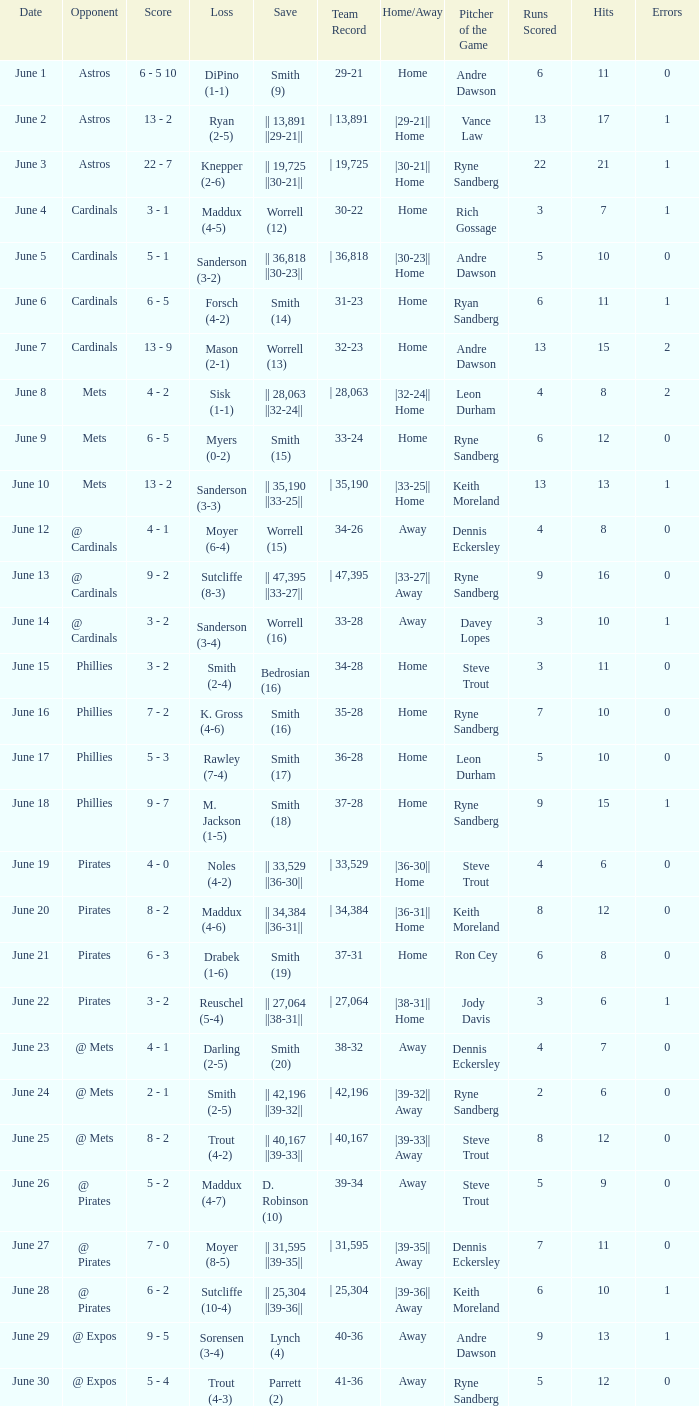What is the loss for the game against @ expos, with a save of parrett (2)? Trout (4-3). Would you mind parsing the complete table? {'header': ['Date', 'Opponent', 'Score', 'Loss', 'Save', 'Team Record', 'Home/Away', 'Pitcher of the Game', 'Runs Scored', 'Hits', 'Errors'], 'rows': [['June 1', 'Astros', '6 - 5 10', 'DiPino (1-1)', 'Smith (9)', '29-21', 'Home', 'Andre Dawson', '6', '11', '0'], ['June 2', 'Astros', '13 - 2', 'Ryan (2-5)', '|| 13,891 ||29-21||', '| 13,891', '|29-21|| Home', 'Vance Law', '13', '17', '1'], ['June 3', 'Astros', '22 - 7', 'Knepper (2-6)', '|| 19,725 ||30-21||', '| 19,725', '|30-21|| Home', 'Ryne Sandberg', '22', '21', '1'], ['June 4', 'Cardinals', '3 - 1', 'Maddux (4-5)', 'Worrell (12)', '30-22', 'Home', 'Rich Gossage', '3', '7', '1'], ['June 5', 'Cardinals', '5 - 1', 'Sanderson (3-2)', '|| 36,818 ||30-23||', '| 36,818', '|30-23|| Home', 'Andre Dawson', '5', '10', '0'], ['June 6', 'Cardinals', '6 - 5', 'Forsch (4-2)', 'Smith (14)', '31-23', 'Home', 'Ryan Sandberg', '6', '11', '1'], ['June 7', 'Cardinals', '13 - 9', 'Mason (2-1)', 'Worrell (13)', '32-23', 'Home', 'Andre Dawson', '13', '15', '2'], ['June 8', 'Mets', '4 - 2', 'Sisk (1-1)', '|| 28,063 ||32-24||', '| 28,063', '|32-24|| Home', 'Leon Durham', '4', '8', '2'], ['June 9', 'Mets', '6 - 5', 'Myers (0-2)', 'Smith (15)', '33-24', 'Home', 'Ryne Sandberg', '6', '12', '0'], ['June 10', 'Mets', '13 - 2', 'Sanderson (3-3)', '|| 35,190 ||33-25||', '| 35,190', '|33-25|| Home', 'Keith Moreland', '13', '13', '1'], ['June 12', '@ Cardinals', '4 - 1', 'Moyer (6-4)', 'Worrell (15)', '34-26', 'Away', 'Dennis Eckersley', '4', '8', '0'], ['June 13', '@ Cardinals', '9 - 2', 'Sutcliffe (8-3)', '|| 47,395 ||33-27||', '| 47,395', '|33-27|| Away', 'Ryne Sandberg', '9', '16', '0'], ['June 14', '@ Cardinals', '3 - 2', 'Sanderson (3-4)', 'Worrell (16)', '33-28', 'Away', 'Davey Lopes', '3', '10', '1'], ['June 15', 'Phillies', '3 - 2', 'Smith (2-4)', 'Bedrosian (16)', '34-28', 'Home', 'Steve Trout', '3', '11', '0'], ['June 16', 'Phillies', '7 - 2', 'K. Gross (4-6)', 'Smith (16)', '35-28', 'Home', 'Ryne Sandberg', '7', '10', '0'], ['June 17', 'Phillies', '5 - 3', 'Rawley (7-4)', 'Smith (17)', '36-28', 'Home', 'Leon Durham', '5', '10', '0'], ['June 18', 'Phillies', '9 - 7', 'M. Jackson (1-5)', 'Smith (18)', '37-28', 'Home', 'Ryne Sandberg', '9', '15', '1'], ['June 19', 'Pirates', '4 - 0', 'Noles (4-2)', '|| 33,529 ||36-30||', '| 33,529', '|36-30|| Home', 'Steve Trout', '4', '6', '0'], ['June 20', 'Pirates', '8 - 2', 'Maddux (4-6)', '|| 34,384 ||36-31||', '| 34,384', '|36-31|| Home', 'Keith Moreland', '8', '12', '0'], ['June 21', 'Pirates', '6 - 3', 'Drabek (1-6)', 'Smith (19)', '37-31', 'Home', 'Ron Cey', '6', '8', '0'], ['June 22', 'Pirates', '3 - 2', 'Reuschel (5-4)', '|| 27,064 ||38-31||', '| 27,064', '|38-31|| Home', 'Jody Davis', '3', '6', '1'], ['June 23', '@ Mets', '4 - 1', 'Darling (2-5)', 'Smith (20)', '38-32', 'Away', 'Dennis Eckersley', '4', '7', '0'], ['June 24', '@ Mets', '2 - 1', 'Smith (2-5)', '|| 42,196 ||39-32||', '| 42,196', '|39-32|| Away', 'Ryne Sandberg', '2', '6', '0'], ['June 25', '@ Mets', '8 - 2', 'Trout (4-2)', '|| 40,167 ||39-33||', '| 40,167', '|39-33|| Away', 'Steve Trout', '8', '12', '0'], ['June 26', '@ Pirates', '5 - 2', 'Maddux (4-7)', 'D. Robinson (10)', '39-34', 'Away', 'Steve Trout', '5', '9', '0'], ['June 27', '@ Pirates', '7 - 0', 'Moyer (8-5)', '|| 31,595 ||39-35||', '| 31,595', '|39-35|| Away', 'Dennis Eckersley', '7', '11', '0'], ['June 28', '@ Pirates', '6 - 2', 'Sutcliffe (10-4)', '|| 25,304 ||39-36||', '| 25,304', '|39-36|| Away', 'Keith Moreland', '6', '10', '1'], ['June 29', '@ Expos', '9 - 5', 'Sorensen (3-4)', 'Lynch (4)', '40-36', 'Away', 'Andre Dawson', '9', '13', '1'], ['June 30', '@ Expos', '5 - 4', 'Trout (4-3)', 'Parrett (2)', '41-36', 'Away', 'Ryne Sandberg', '5', '12', '0']]} 